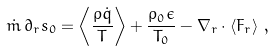Convert formula to latex. <formula><loc_0><loc_0><loc_500><loc_500>\dot { m } \, \partial _ { r } s _ { 0 } = \left < \frac { \rho \dot { q } } { T } \right > + \frac { \rho _ { 0 } \epsilon } { T _ { 0 } } - \nabla _ { r } \cdot \left < F _ { r } \right > \, ,</formula> 